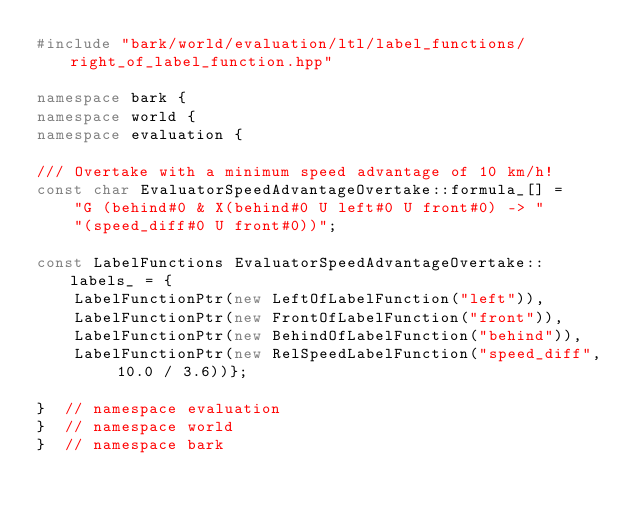Convert code to text. <code><loc_0><loc_0><loc_500><loc_500><_C++_>#include "bark/world/evaluation/ltl/label_functions/right_of_label_function.hpp"

namespace bark {
namespace world {
namespace evaluation {

/// Overtake with a minimum speed advantage of 10 km/h!
const char EvaluatorSpeedAdvantageOvertake::formula_[] =
    "G (behind#0 & X(behind#0 U left#0 U front#0) -> "
    "(speed_diff#0 U front#0))";

const LabelFunctions EvaluatorSpeedAdvantageOvertake::labels_ = {
    LabelFunctionPtr(new LeftOfLabelFunction("left")),
    LabelFunctionPtr(new FrontOfLabelFunction("front")),
    LabelFunctionPtr(new BehindOfLabelFunction("behind")),
    LabelFunctionPtr(new RelSpeedLabelFunction("speed_diff", 10.0 / 3.6))};

}  // namespace evaluation
}  // namespace world
}  // namespace bark
</code> 